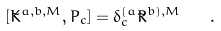Convert formula to latex. <formula><loc_0><loc_0><loc_500><loc_500>[ \tilde { K } ^ { a , b , M } , P _ { c } ] = \delta ^ { ( a } _ { c } \tilde { R } ^ { b ) , M } \quad .</formula> 